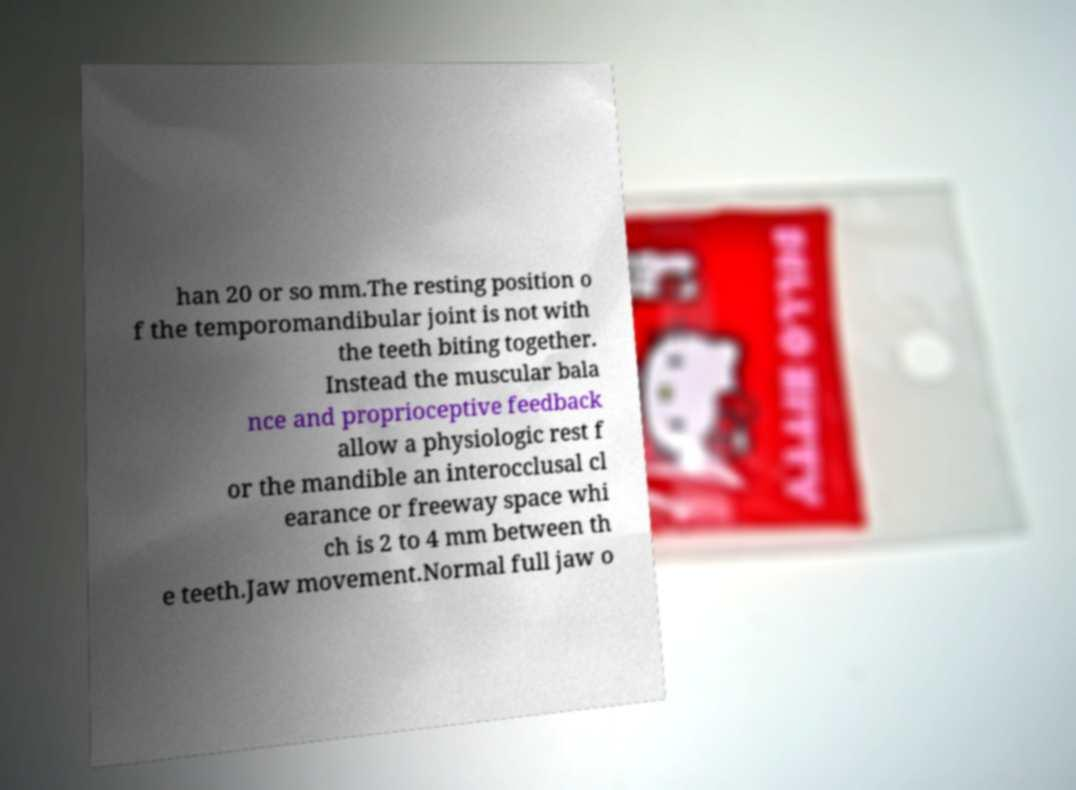Please read and relay the text visible in this image. What does it say? han 20 or so mm.The resting position o f the temporomandibular joint is not with the teeth biting together. Instead the muscular bala nce and proprioceptive feedback allow a physiologic rest f or the mandible an interocclusal cl earance or freeway space whi ch is 2 to 4 mm between th e teeth.Jaw movement.Normal full jaw o 